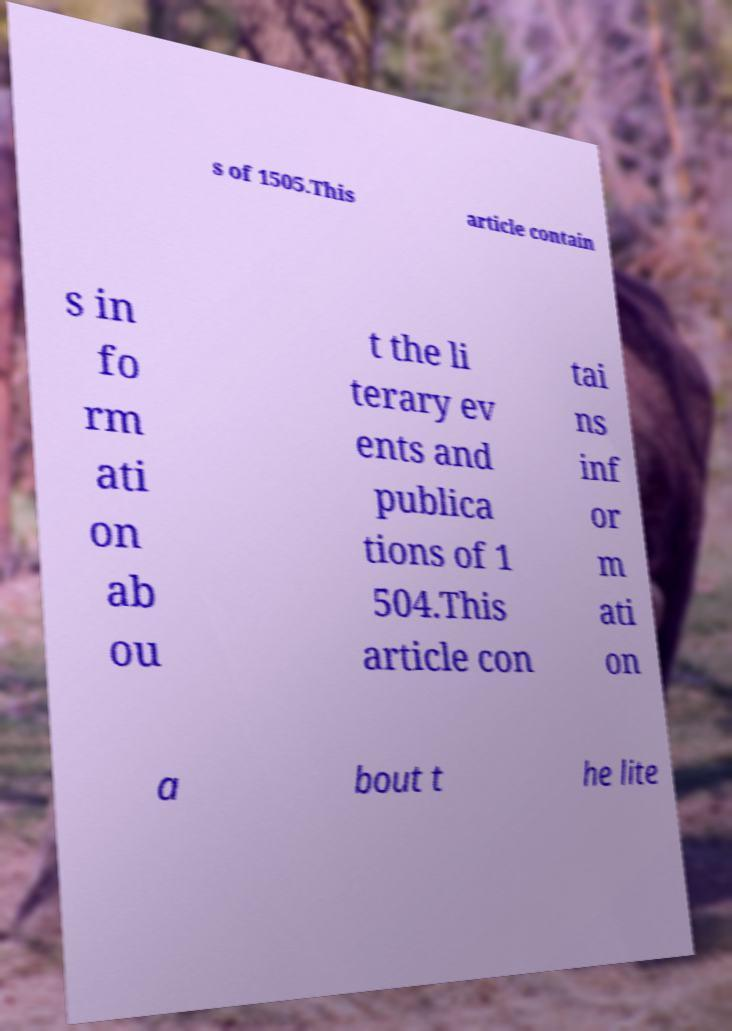Please identify and transcribe the text found in this image. s of 1505.This article contain s in fo rm ati on ab ou t the li terary ev ents and publica tions of 1 504.This article con tai ns inf or m ati on a bout t he lite 